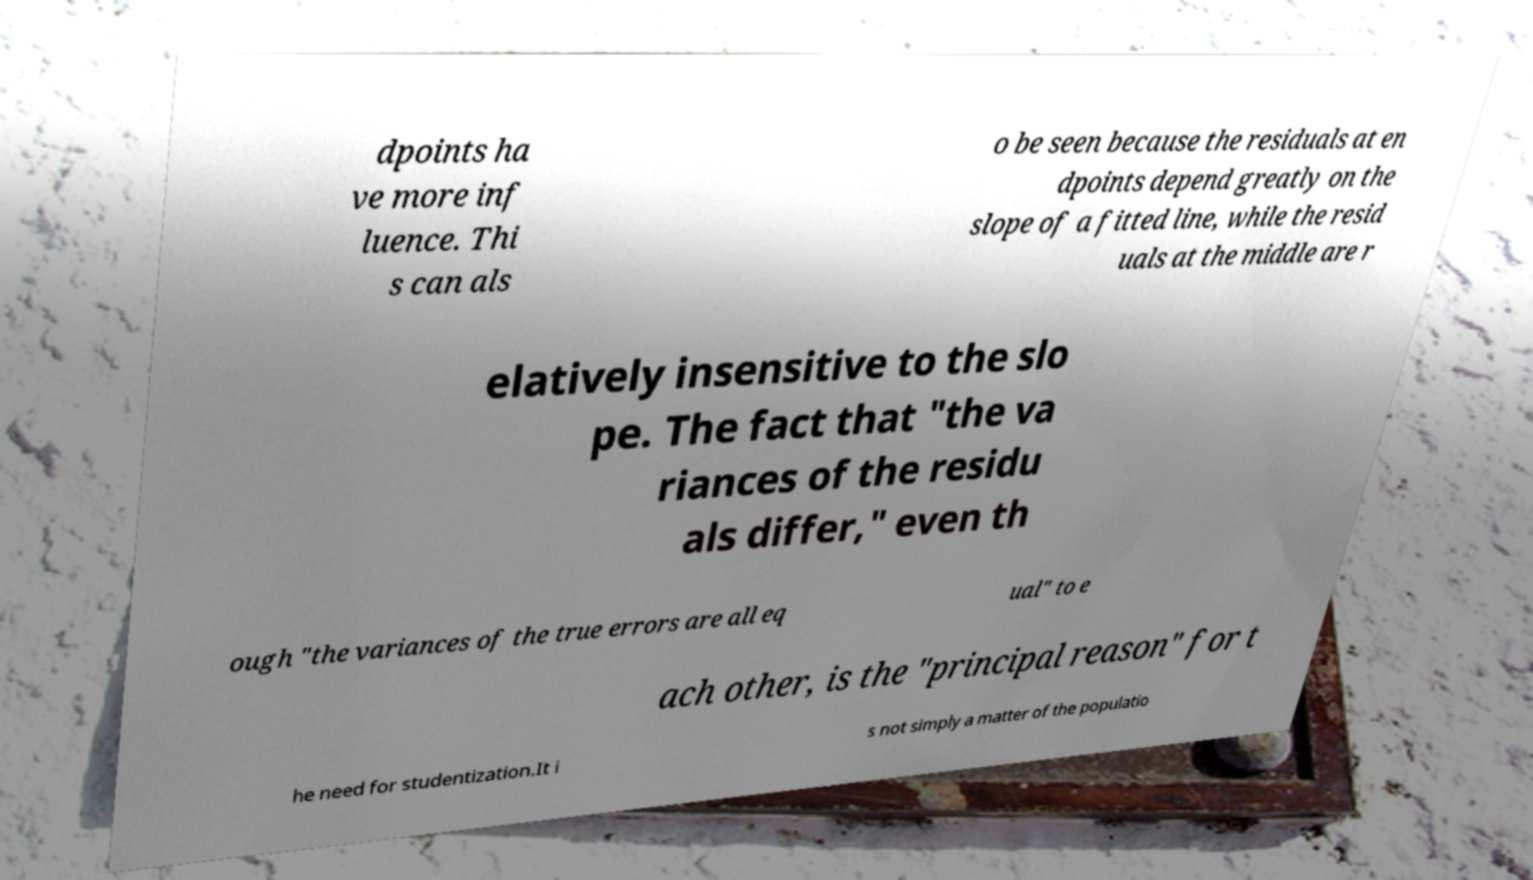Can you accurately transcribe the text from the provided image for me? dpoints ha ve more inf luence. Thi s can als o be seen because the residuals at en dpoints depend greatly on the slope of a fitted line, while the resid uals at the middle are r elatively insensitive to the slo pe. The fact that "the va riances of the residu als differ," even th ough "the variances of the true errors are all eq ual" to e ach other, is the "principal reason" for t he need for studentization.It i s not simply a matter of the populatio 